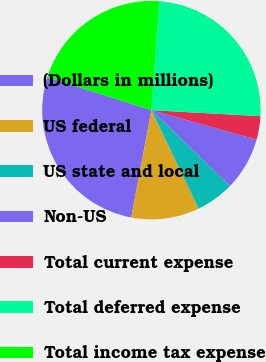Convert chart. <chart><loc_0><loc_0><loc_500><loc_500><pie_chart><fcel>(Dollars in millions)<fcel>US federal<fcel>US state and local<fcel>Non-US<fcel>Total current expense<fcel>Total deferred expense<fcel>Total income tax expense<nl><fcel>26.93%<fcel>10.08%<fcel>5.67%<fcel>7.87%<fcel>3.46%<fcel>24.73%<fcel>21.26%<nl></chart> 